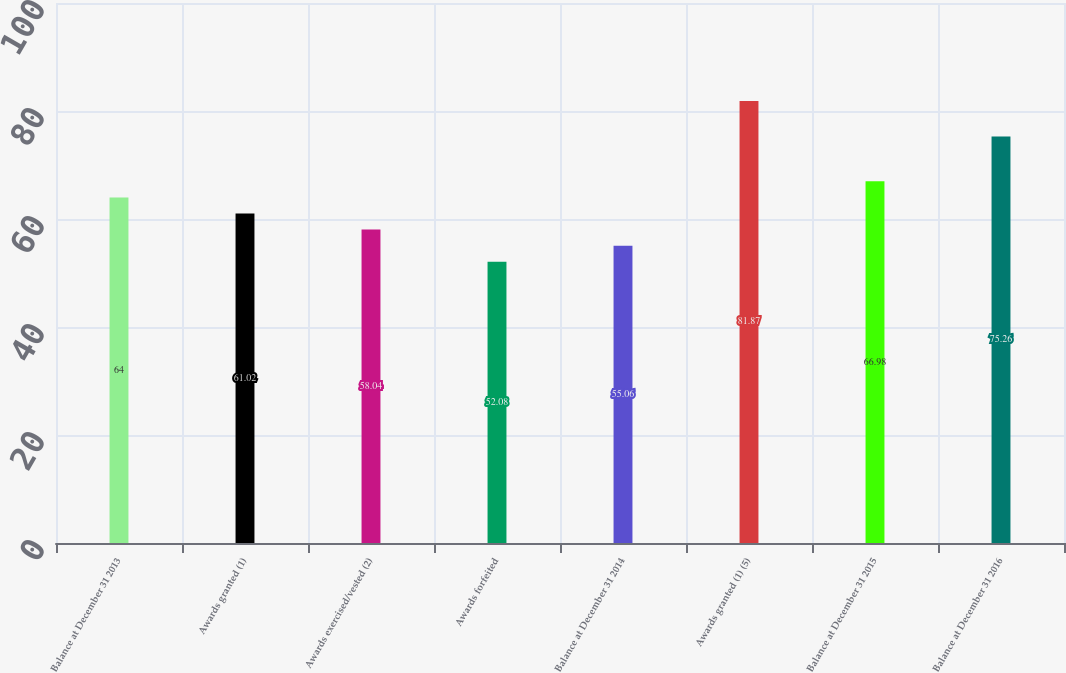Convert chart to OTSL. <chart><loc_0><loc_0><loc_500><loc_500><bar_chart><fcel>Balance at December 31 2013<fcel>Awards granted (1)<fcel>Awards exercised/vested (2)<fcel>Awards forfeited<fcel>Balance at December 31 2014<fcel>Awards granted (1) (5)<fcel>Balance at December 31 2015<fcel>Balance at December 31 2016<nl><fcel>64<fcel>61.02<fcel>58.04<fcel>52.08<fcel>55.06<fcel>81.87<fcel>66.98<fcel>75.26<nl></chart> 